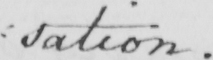What text is written in this handwritten line? : sation . 